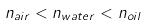<formula> <loc_0><loc_0><loc_500><loc_500>n _ { a i r } < n _ { w a t e r } < n _ { o i l }</formula> 